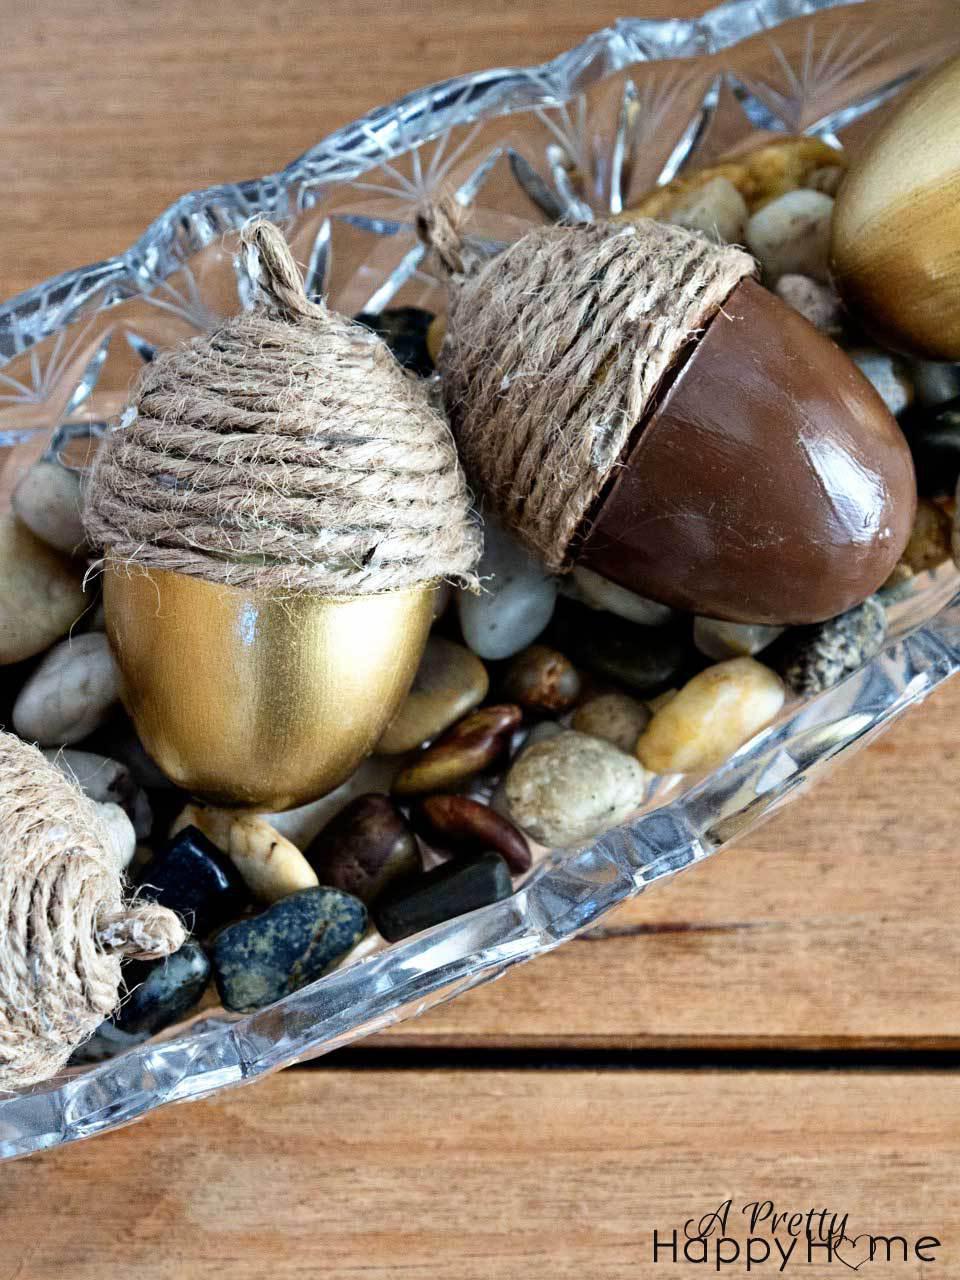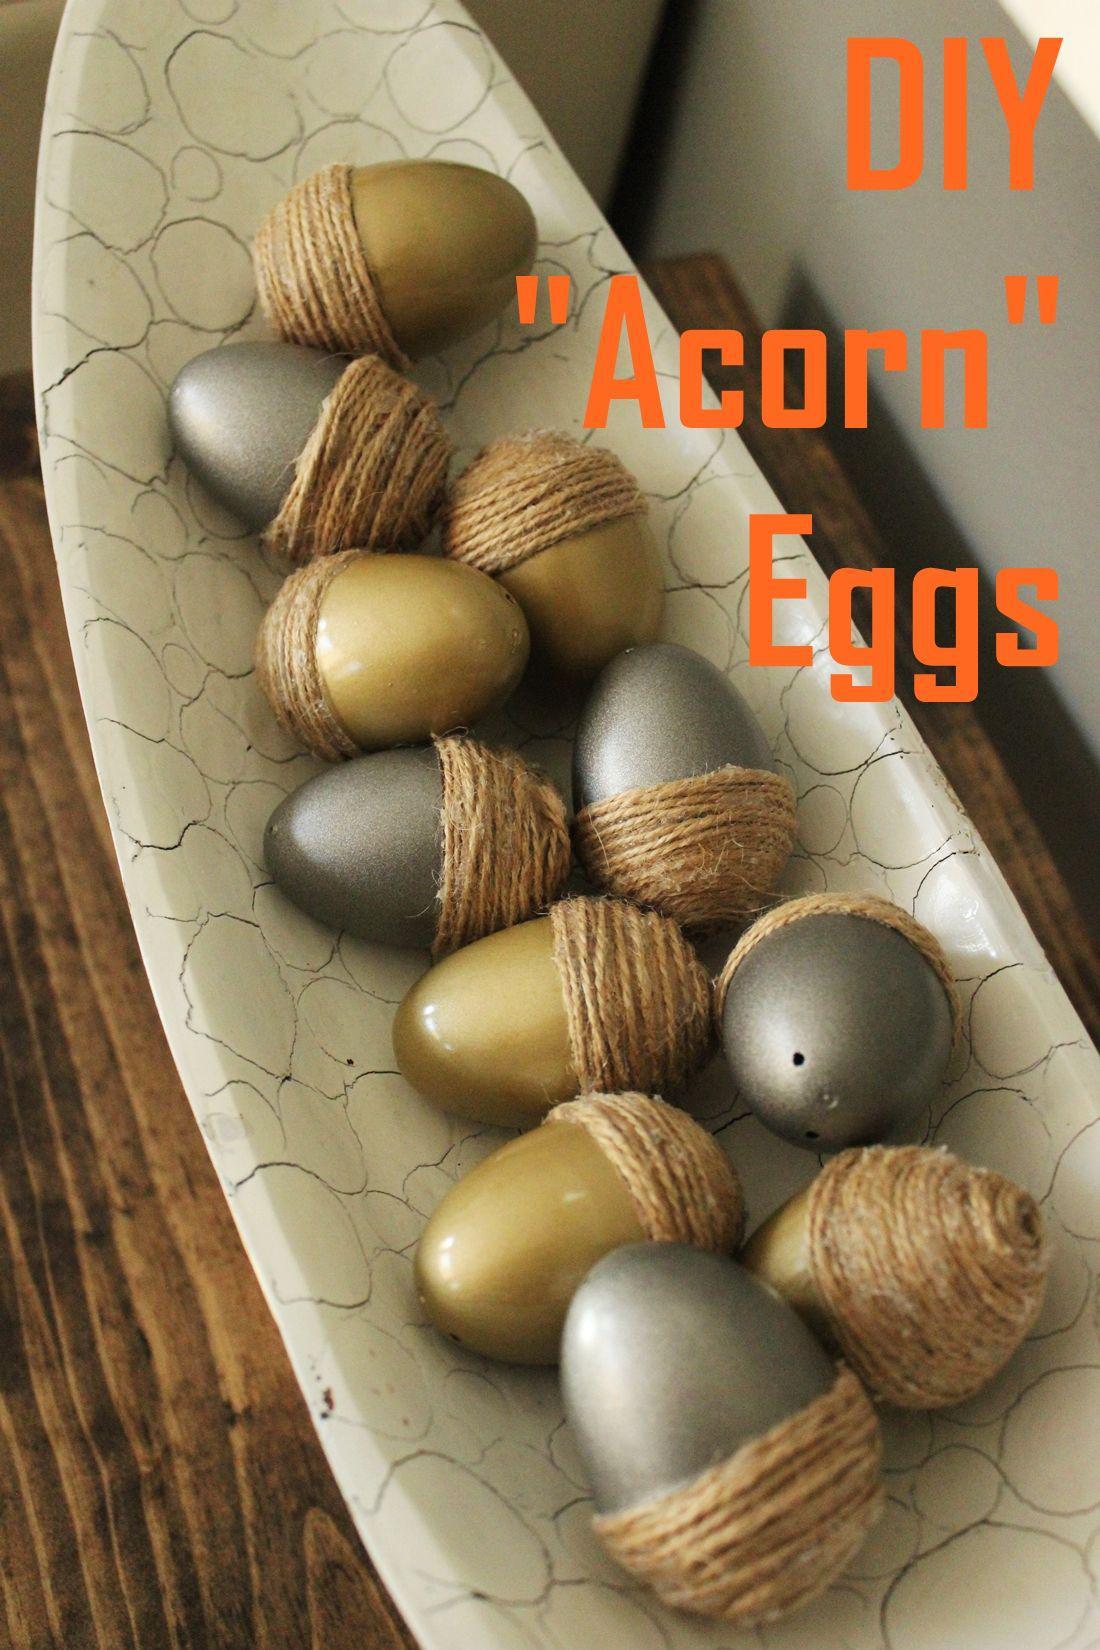The first image is the image on the left, the second image is the image on the right. Given the left and right images, does the statement "The acorns in the left image are in a glass dish." hold true? Answer yes or no. Yes. The first image is the image on the left, the second image is the image on the right. Assess this claim about the two images: "The left image shows two 'acorn eggs' - one gold and one brown - in an oblong scalloped glass bowl containing smooth stones.". Correct or not? Answer yes or no. Yes. 